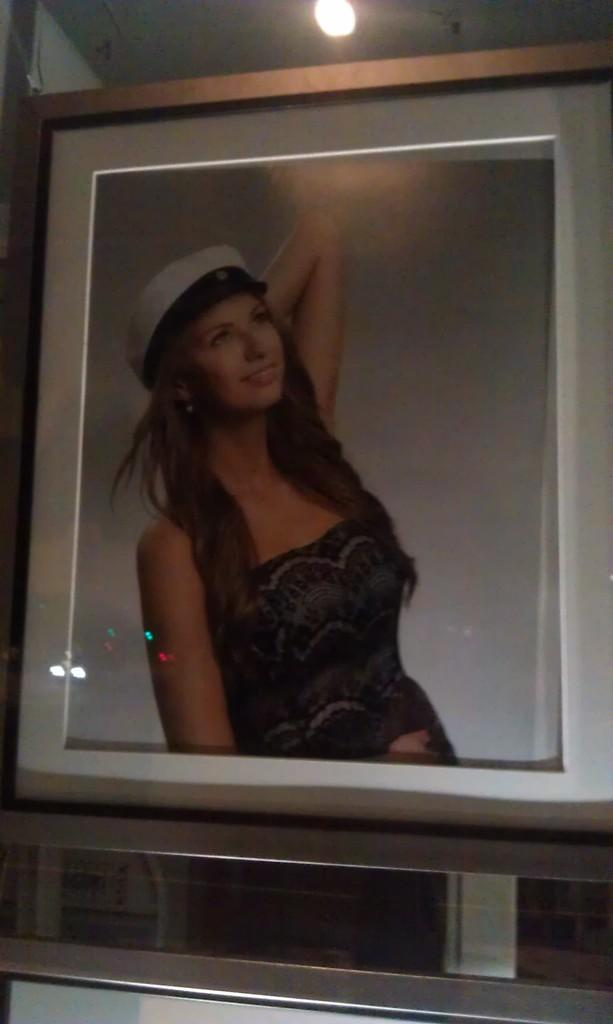What object is present in the image that holds a picture? There is a photo frame in the image that contains a picture of a woman. What can be seen above the photo frame in the image? There is a roof visible above the photo frame, and a light is present on the roof. What is the color of the bottom part of the image? The bottom part of the image is white in color. What is the rate of religious waste in the image? There is no mention of religion or waste in the image, so it is not possible to determine a rate. 